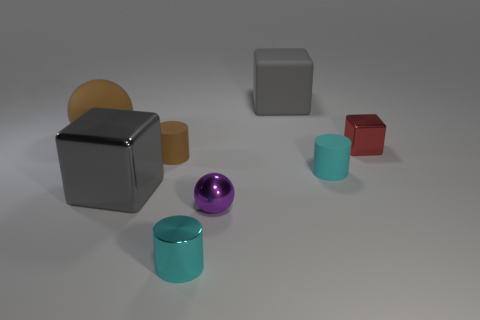Add 1 metallic cylinders. How many objects exist? 9 Subtract all cylinders. How many objects are left? 5 Add 2 large metallic things. How many large metallic things exist? 3 Subtract 1 red blocks. How many objects are left? 7 Subtract all large matte spheres. Subtract all green matte things. How many objects are left? 7 Add 2 cubes. How many cubes are left? 5 